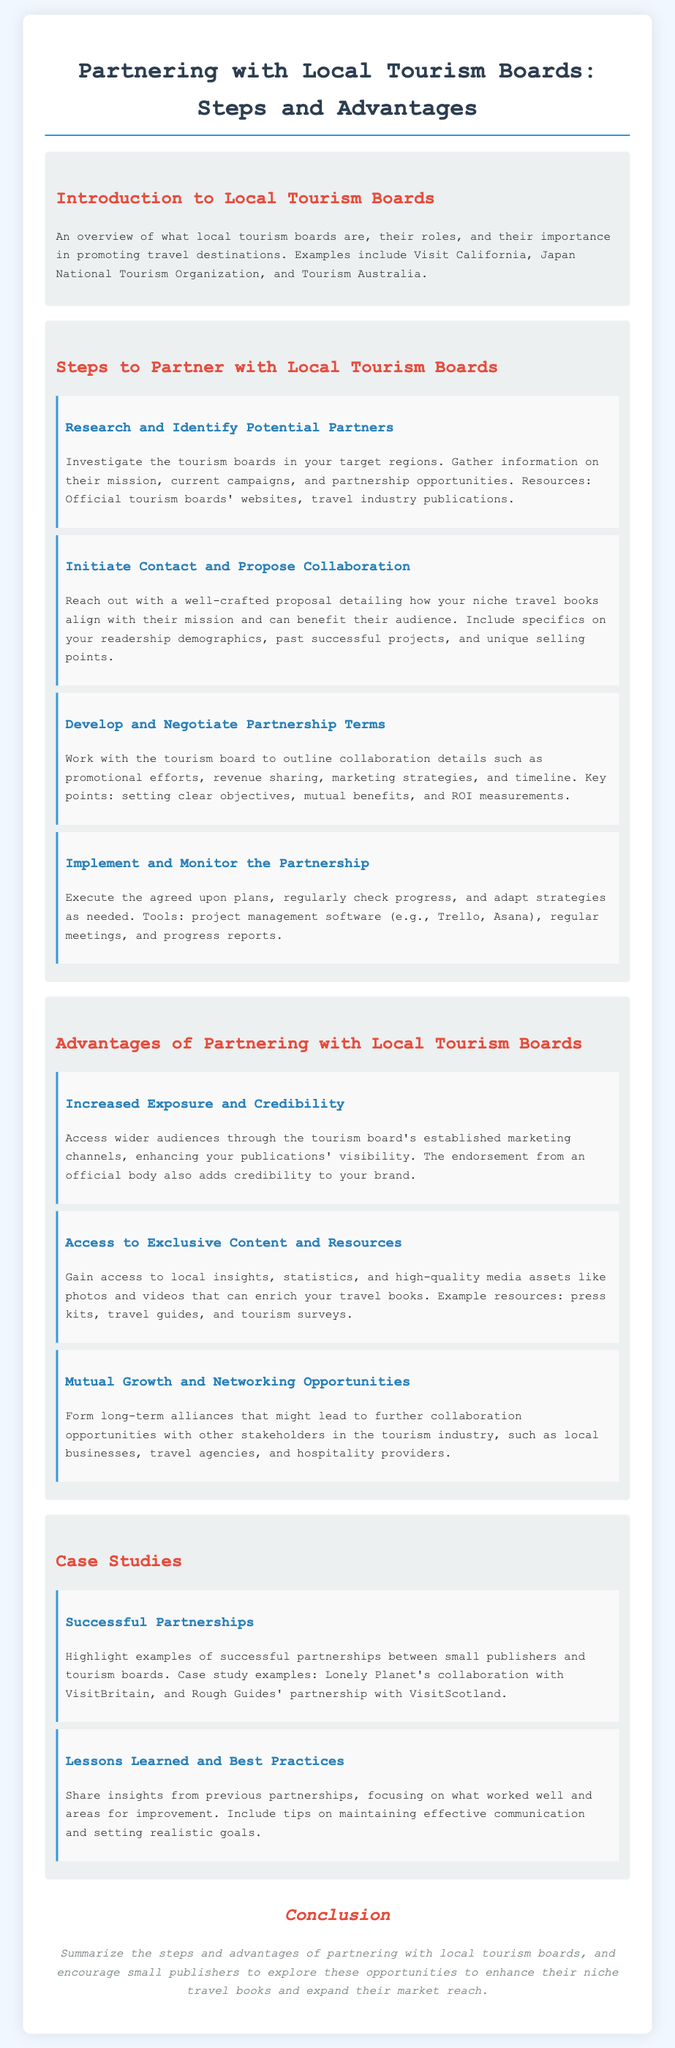What are local tourism boards? Local tourism boards are organizations that promote travel destinations and support local tourism.
Answer: Organizations What is the first step to partner with local tourism boards? The first step is to research and identify potential partners in target regions, gathering relevant information.
Answer: Research and Identify Potential Partners What is one advantage of partnering with local tourism boards? One advantage is increased exposure and credibility through established marketing channels of the tourism board.
Answer: Increased Exposure and Credibility Which project management software is suggested for monitoring the partnership? Suggested project management software includes Trello and Asana for tracking progress and tasks.
Answer: Trello, Asana Name a case study example of a successful partnership. A case study example is the collaboration between Lonely Planet and VisitBritain.
Answer: Lonely Planet's collaboration with VisitBritain What is a resource mentioned to gain access to exclusive content? One resource mentioned is press kits, which provide valuable insights and media assets.
Answer: Press kits How does collaborating with tourism boards foster networking opportunities? Collaborating can lead to forming alliances with other stakeholders like local businesses and travel agencies.
Answer: Long-term alliances What should be included in the proposal to tourism boards? The proposal should detail how the niche travel books align with their mission and benefit their audience.
Answer: Proposal detailing alignment and benefits What is the conclusion of the document about? The conclusion summarizes the steps and advantages of partnering with local tourism boards and encourages exploration of these opportunities.
Answer: Summarizing steps and advantages 